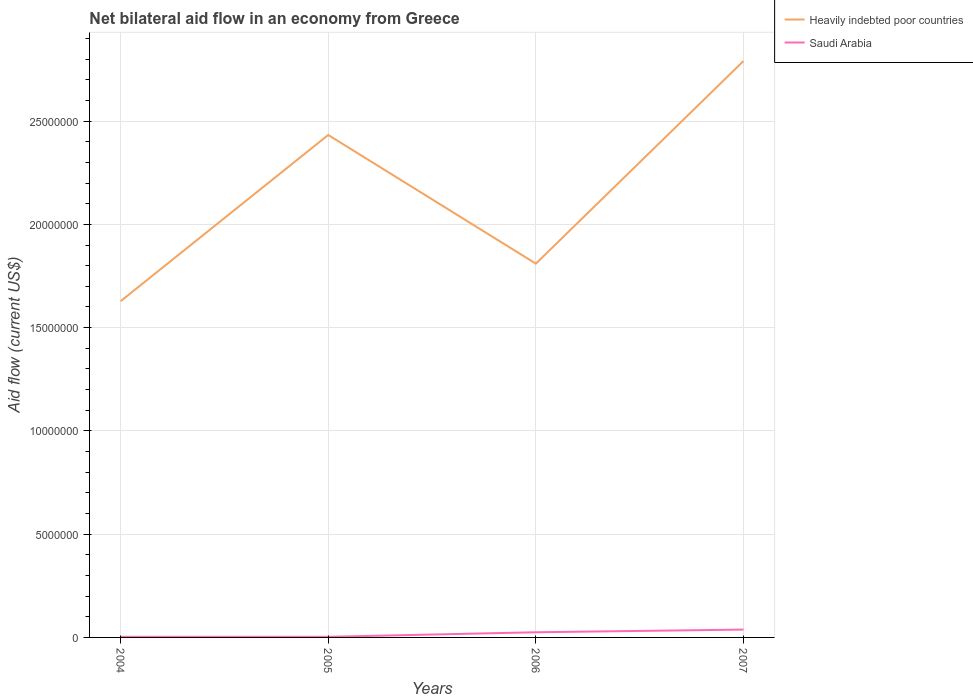How many different coloured lines are there?
Your answer should be compact. 2. Does the line corresponding to Heavily indebted poor countries intersect with the line corresponding to Saudi Arabia?
Give a very brief answer. No. Is the number of lines equal to the number of legend labels?
Ensure brevity in your answer.  Yes. In which year was the net bilateral aid flow in Heavily indebted poor countries maximum?
Make the answer very short. 2004. What is the total net bilateral aid flow in Saudi Arabia in the graph?
Ensure brevity in your answer.  -2.20e+05. What is the difference between the highest and the second highest net bilateral aid flow in Saudi Arabia?
Your answer should be compact. 3.50e+05. Is the net bilateral aid flow in Saudi Arabia strictly greater than the net bilateral aid flow in Heavily indebted poor countries over the years?
Provide a short and direct response. Yes. How many lines are there?
Give a very brief answer. 2. What is the difference between two consecutive major ticks on the Y-axis?
Offer a terse response. 5.00e+06. Are the values on the major ticks of Y-axis written in scientific E-notation?
Ensure brevity in your answer.  No. Does the graph contain grids?
Offer a terse response. Yes. Where does the legend appear in the graph?
Your response must be concise. Top right. How many legend labels are there?
Provide a short and direct response. 2. What is the title of the graph?
Make the answer very short. Net bilateral aid flow in an economy from Greece. What is the label or title of the Y-axis?
Keep it short and to the point. Aid flow (current US$). What is the Aid flow (current US$) in Heavily indebted poor countries in 2004?
Ensure brevity in your answer.  1.63e+07. What is the Aid flow (current US$) in Heavily indebted poor countries in 2005?
Give a very brief answer. 2.43e+07. What is the Aid flow (current US$) in Heavily indebted poor countries in 2006?
Your answer should be very brief. 1.81e+07. What is the Aid flow (current US$) of Heavily indebted poor countries in 2007?
Offer a very short reply. 2.79e+07. What is the Aid flow (current US$) in Saudi Arabia in 2007?
Offer a very short reply. 3.80e+05. Across all years, what is the maximum Aid flow (current US$) in Heavily indebted poor countries?
Your response must be concise. 2.79e+07. Across all years, what is the maximum Aid flow (current US$) in Saudi Arabia?
Your answer should be compact. 3.80e+05. Across all years, what is the minimum Aid flow (current US$) of Heavily indebted poor countries?
Your answer should be very brief. 1.63e+07. Across all years, what is the minimum Aid flow (current US$) of Saudi Arabia?
Keep it short and to the point. 3.00e+04. What is the total Aid flow (current US$) of Heavily indebted poor countries in the graph?
Provide a short and direct response. 8.66e+07. What is the total Aid flow (current US$) in Saudi Arabia in the graph?
Offer a very short reply. 6.90e+05. What is the difference between the Aid flow (current US$) in Heavily indebted poor countries in 2004 and that in 2005?
Your answer should be compact. -8.05e+06. What is the difference between the Aid flow (current US$) of Saudi Arabia in 2004 and that in 2005?
Keep it short and to the point. 0. What is the difference between the Aid flow (current US$) in Heavily indebted poor countries in 2004 and that in 2006?
Provide a succinct answer. -1.82e+06. What is the difference between the Aid flow (current US$) of Heavily indebted poor countries in 2004 and that in 2007?
Ensure brevity in your answer.  -1.16e+07. What is the difference between the Aid flow (current US$) in Saudi Arabia in 2004 and that in 2007?
Your answer should be very brief. -3.50e+05. What is the difference between the Aid flow (current US$) of Heavily indebted poor countries in 2005 and that in 2006?
Offer a terse response. 6.23e+06. What is the difference between the Aid flow (current US$) of Saudi Arabia in 2005 and that in 2006?
Offer a very short reply. -2.20e+05. What is the difference between the Aid flow (current US$) of Heavily indebted poor countries in 2005 and that in 2007?
Your response must be concise. -3.58e+06. What is the difference between the Aid flow (current US$) in Saudi Arabia in 2005 and that in 2007?
Your answer should be compact. -3.50e+05. What is the difference between the Aid flow (current US$) of Heavily indebted poor countries in 2006 and that in 2007?
Provide a succinct answer. -9.81e+06. What is the difference between the Aid flow (current US$) of Saudi Arabia in 2006 and that in 2007?
Keep it short and to the point. -1.30e+05. What is the difference between the Aid flow (current US$) in Heavily indebted poor countries in 2004 and the Aid flow (current US$) in Saudi Arabia in 2005?
Keep it short and to the point. 1.62e+07. What is the difference between the Aid flow (current US$) in Heavily indebted poor countries in 2004 and the Aid flow (current US$) in Saudi Arabia in 2006?
Offer a very short reply. 1.60e+07. What is the difference between the Aid flow (current US$) in Heavily indebted poor countries in 2004 and the Aid flow (current US$) in Saudi Arabia in 2007?
Your answer should be compact. 1.59e+07. What is the difference between the Aid flow (current US$) in Heavily indebted poor countries in 2005 and the Aid flow (current US$) in Saudi Arabia in 2006?
Your response must be concise. 2.41e+07. What is the difference between the Aid flow (current US$) of Heavily indebted poor countries in 2005 and the Aid flow (current US$) of Saudi Arabia in 2007?
Ensure brevity in your answer.  2.40e+07. What is the difference between the Aid flow (current US$) in Heavily indebted poor countries in 2006 and the Aid flow (current US$) in Saudi Arabia in 2007?
Offer a very short reply. 1.77e+07. What is the average Aid flow (current US$) in Heavily indebted poor countries per year?
Provide a succinct answer. 2.17e+07. What is the average Aid flow (current US$) in Saudi Arabia per year?
Offer a terse response. 1.72e+05. In the year 2004, what is the difference between the Aid flow (current US$) in Heavily indebted poor countries and Aid flow (current US$) in Saudi Arabia?
Your answer should be compact. 1.62e+07. In the year 2005, what is the difference between the Aid flow (current US$) of Heavily indebted poor countries and Aid flow (current US$) of Saudi Arabia?
Your answer should be very brief. 2.43e+07. In the year 2006, what is the difference between the Aid flow (current US$) of Heavily indebted poor countries and Aid flow (current US$) of Saudi Arabia?
Make the answer very short. 1.78e+07. In the year 2007, what is the difference between the Aid flow (current US$) in Heavily indebted poor countries and Aid flow (current US$) in Saudi Arabia?
Provide a succinct answer. 2.75e+07. What is the ratio of the Aid flow (current US$) in Heavily indebted poor countries in 2004 to that in 2005?
Ensure brevity in your answer.  0.67. What is the ratio of the Aid flow (current US$) in Heavily indebted poor countries in 2004 to that in 2006?
Give a very brief answer. 0.9. What is the ratio of the Aid flow (current US$) in Saudi Arabia in 2004 to that in 2006?
Offer a very short reply. 0.12. What is the ratio of the Aid flow (current US$) of Heavily indebted poor countries in 2004 to that in 2007?
Make the answer very short. 0.58. What is the ratio of the Aid flow (current US$) of Saudi Arabia in 2004 to that in 2007?
Your answer should be compact. 0.08. What is the ratio of the Aid flow (current US$) in Heavily indebted poor countries in 2005 to that in 2006?
Ensure brevity in your answer.  1.34. What is the ratio of the Aid flow (current US$) in Saudi Arabia in 2005 to that in 2006?
Ensure brevity in your answer.  0.12. What is the ratio of the Aid flow (current US$) in Heavily indebted poor countries in 2005 to that in 2007?
Offer a very short reply. 0.87. What is the ratio of the Aid flow (current US$) of Saudi Arabia in 2005 to that in 2007?
Provide a succinct answer. 0.08. What is the ratio of the Aid flow (current US$) of Heavily indebted poor countries in 2006 to that in 2007?
Make the answer very short. 0.65. What is the ratio of the Aid flow (current US$) in Saudi Arabia in 2006 to that in 2007?
Make the answer very short. 0.66. What is the difference between the highest and the second highest Aid flow (current US$) of Heavily indebted poor countries?
Provide a short and direct response. 3.58e+06. What is the difference between the highest and the second highest Aid flow (current US$) of Saudi Arabia?
Provide a succinct answer. 1.30e+05. What is the difference between the highest and the lowest Aid flow (current US$) of Heavily indebted poor countries?
Your answer should be very brief. 1.16e+07. 